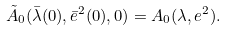Convert formula to latex. <formula><loc_0><loc_0><loc_500><loc_500>\tilde { A } _ { 0 } ( \bar { \lambda } ( 0 ) , \bar { e } ^ { 2 } ( 0 ) , 0 ) = A _ { 0 } ( \lambda , e ^ { 2 } ) .</formula> 